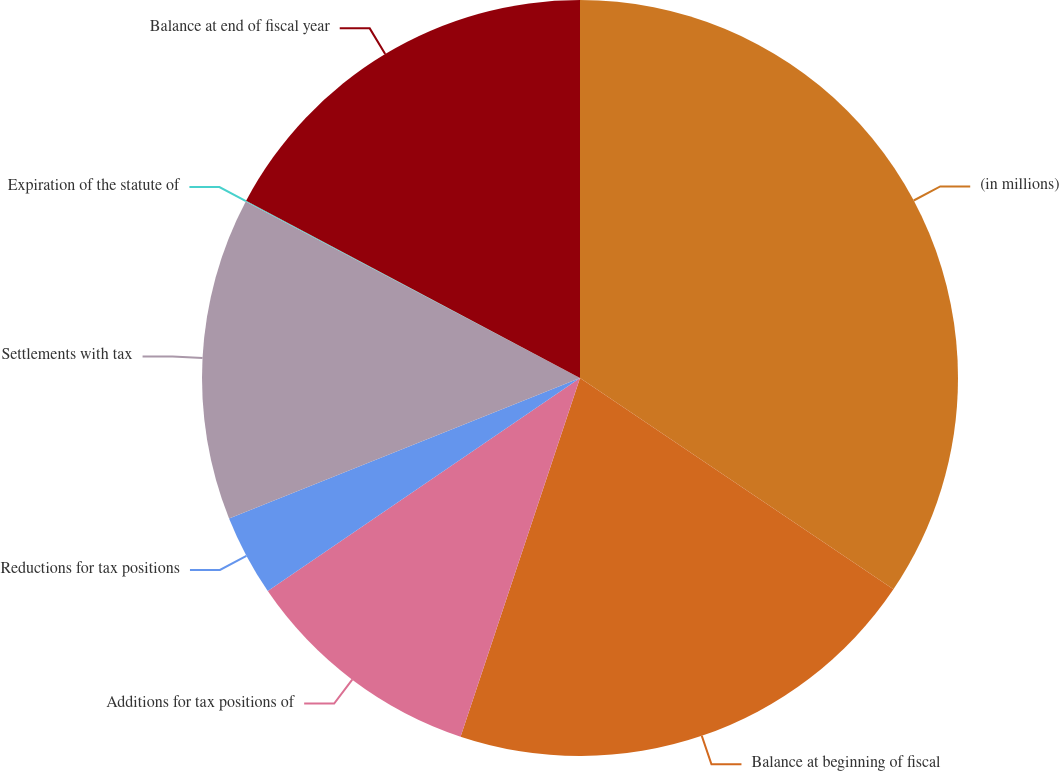Convert chart to OTSL. <chart><loc_0><loc_0><loc_500><loc_500><pie_chart><fcel>(in millions)<fcel>Balance at beginning of fiscal<fcel>Additions for tax positions of<fcel>Reductions for tax positions<fcel>Settlements with tax<fcel>Expiration of the statute of<fcel>Balance at end of fiscal year<nl><fcel>34.43%<fcel>20.67%<fcel>10.35%<fcel>3.47%<fcel>13.79%<fcel>0.03%<fcel>17.23%<nl></chart> 